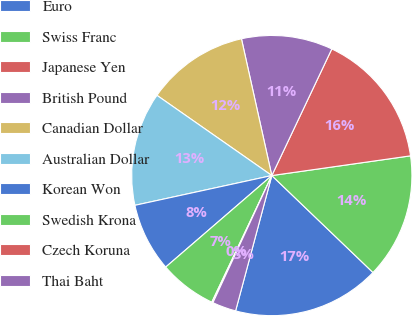Convert chart. <chart><loc_0><loc_0><loc_500><loc_500><pie_chart><fcel>Euro<fcel>Swiss Franc<fcel>Japanese Yen<fcel>British Pound<fcel>Canadian Dollar<fcel>Australian Dollar<fcel>Korean Won<fcel>Swedish Krona<fcel>Czech Koruna<fcel>Thai Baht<nl><fcel>17.0%<fcel>14.41%<fcel>15.71%<fcel>10.52%<fcel>11.82%<fcel>13.11%<fcel>7.92%<fcel>6.63%<fcel>0.14%<fcel>2.74%<nl></chart> 